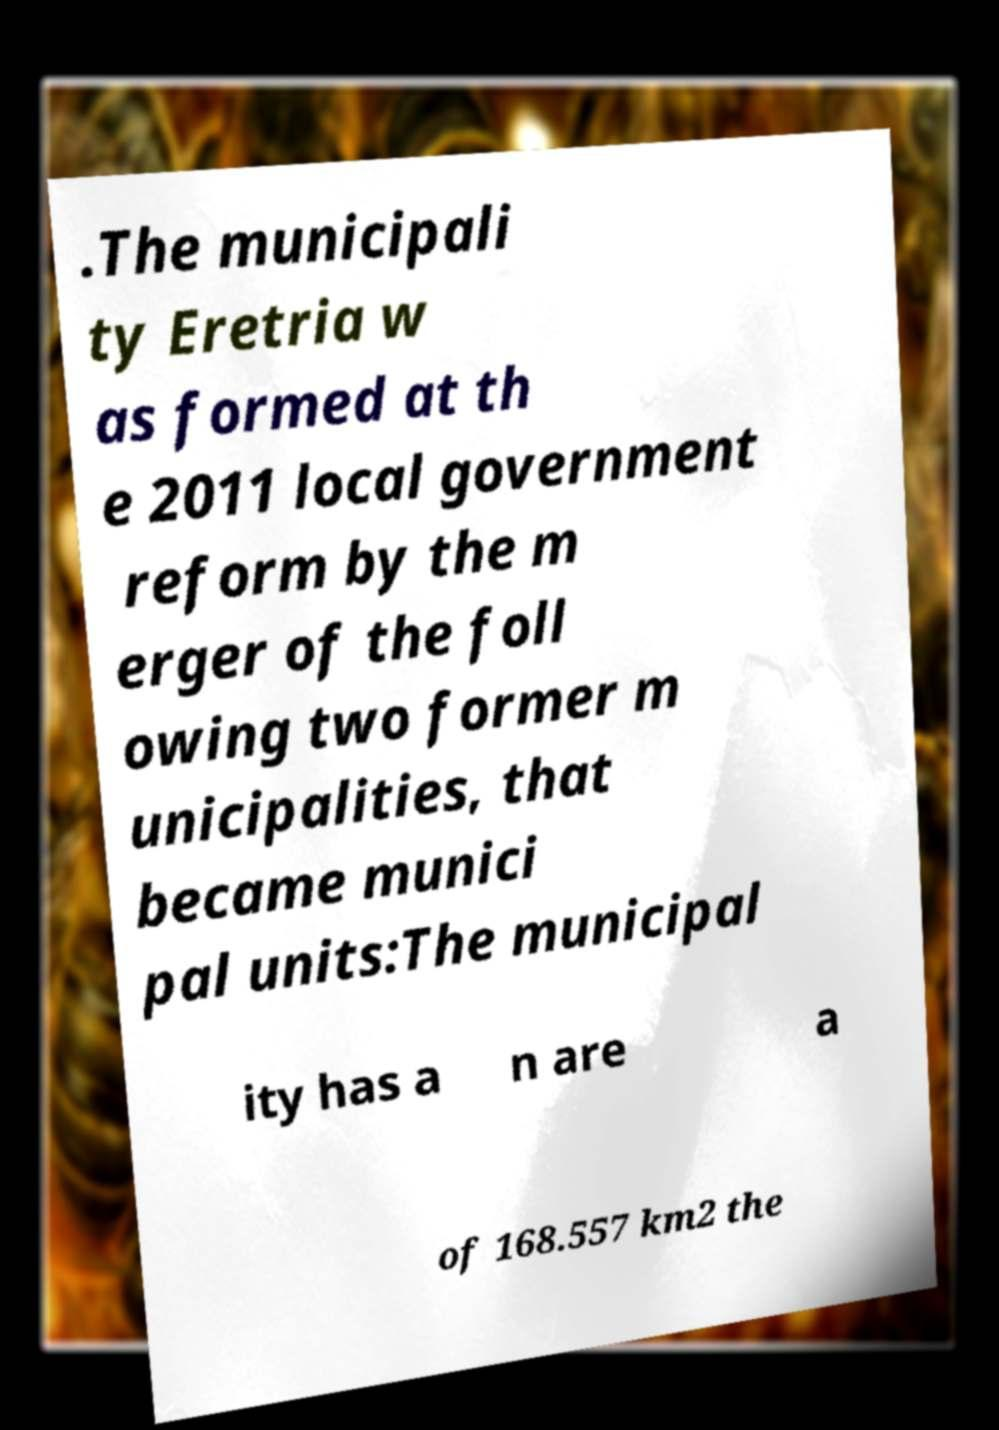For documentation purposes, I need the text within this image transcribed. Could you provide that? .The municipali ty Eretria w as formed at th e 2011 local government reform by the m erger of the foll owing two former m unicipalities, that became munici pal units:The municipal ity has a n are a of 168.557 km2 the 